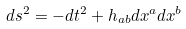Convert formula to latex. <formula><loc_0><loc_0><loc_500><loc_500>d s ^ { 2 } = - d t ^ { 2 } + h _ { a b } d x ^ { a } d x ^ { b }</formula> 